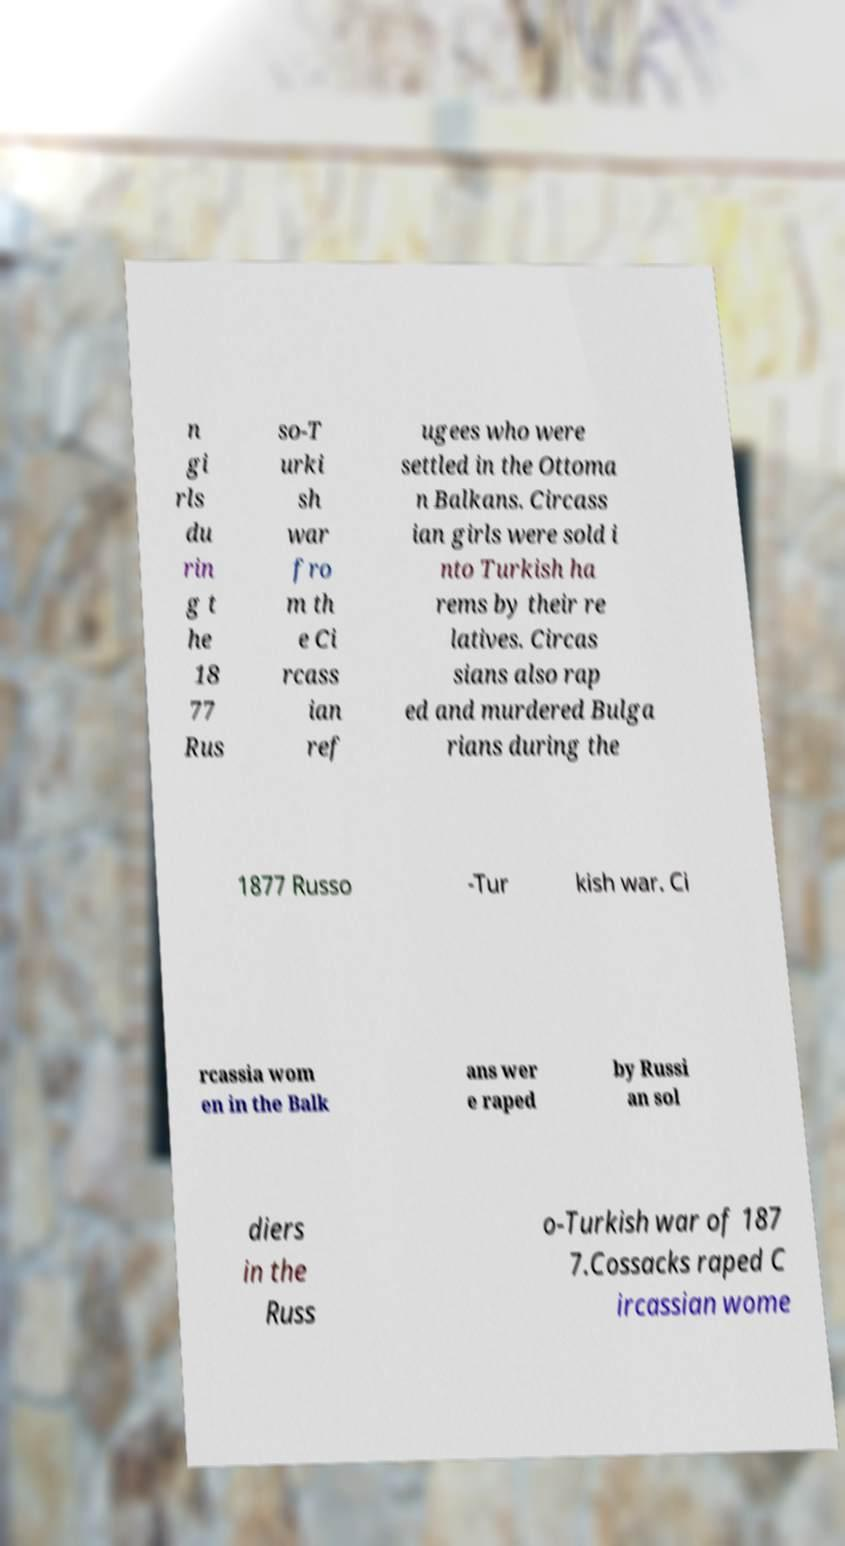What messages or text are displayed in this image? I need them in a readable, typed format. n gi rls du rin g t he 18 77 Rus so-T urki sh war fro m th e Ci rcass ian ref ugees who were settled in the Ottoma n Balkans. Circass ian girls were sold i nto Turkish ha rems by their re latives. Circas sians also rap ed and murdered Bulga rians during the 1877 Russo -Tur kish war. Ci rcassia wom en in the Balk ans wer e raped by Russi an sol diers in the Russ o-Turkish war of 187 7.Cossacks raped C ircassian wome 